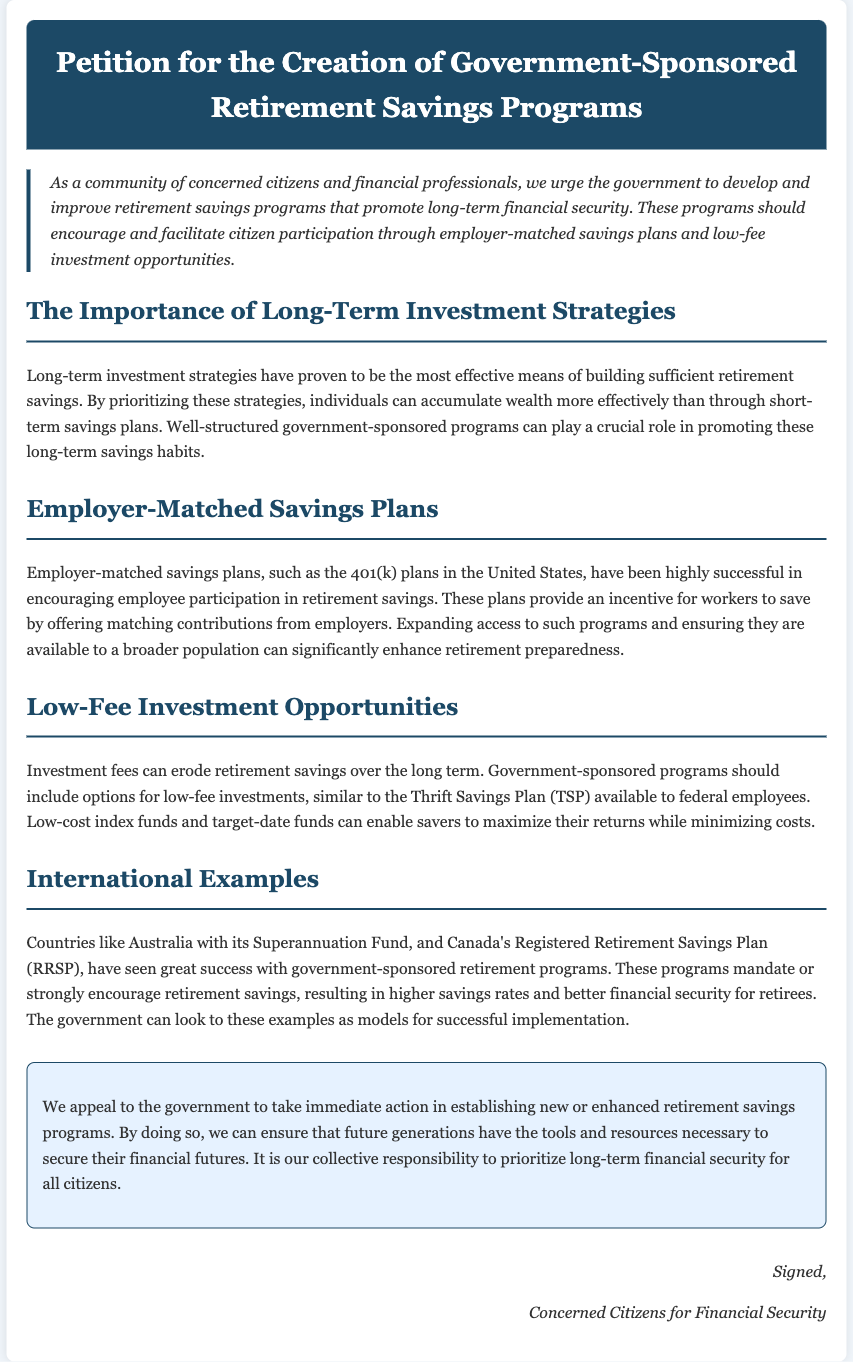What is the title of the petition? The title is found in the header of the document.
Answer: Petition for the Creation of Government-Sponsored Retirement Savings Programs What kind of savings plans are proposed? The document specifically mentions employer-matched savings plans.
Answer: Employer-matched savings plans What do low-fee investment opportunities help minimize? This information can be found in the discussion about investment fees within the document.
Answer: Investment fees Which country is cited as having a successful retirement program? The document provides examples of countries with successful programs.
Answer: Australia What does the petition urge the government to take action on? The main request of the petition is highlighted in the conclusion.
Answer: Establishing new or enhanced retirement savings programs What should the government look to for successful implementation of retirement programs? This information is found in the section discussing international examples.
Answer: International examples Who signed the petition? The signature section indicates the group behind the petition.
Answer: Concerned Citizens for Financial Security What is the primary focus of the petition? The introduction of the document outlines the main aim of the petition.
Answer: Long-term financial security 